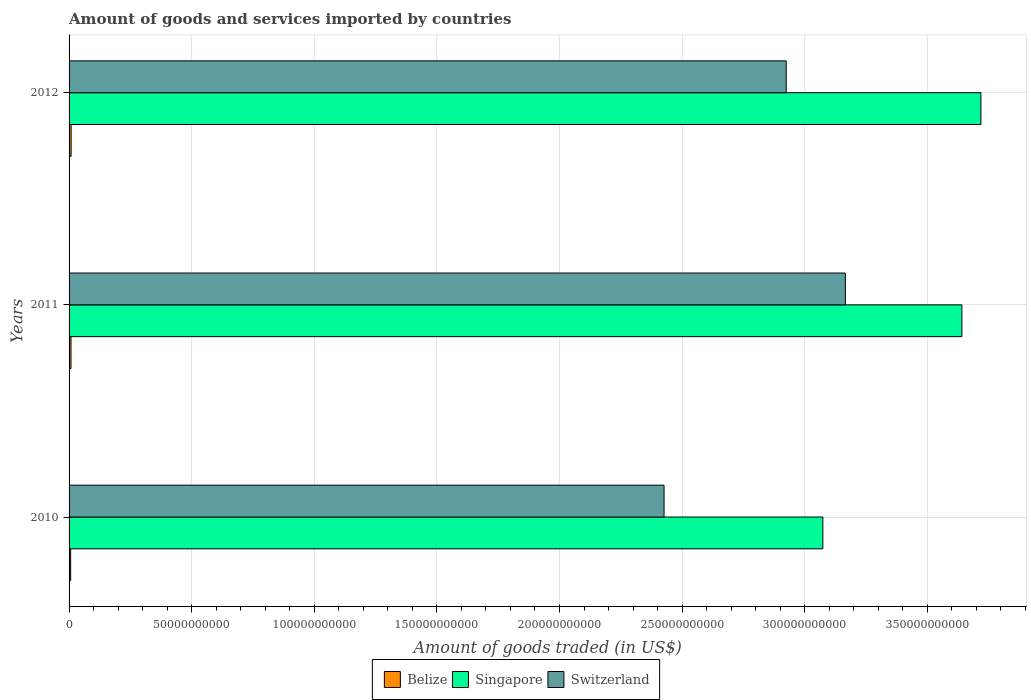How many different coloured bars are there?
Keep it short and to the point. 3. What is the total amount of goods and services imported in Singapore in 2012?
Your answer should be compact. 3.72e+11. Across all years, what is the maximum total amount of goods and services imported in Switzerland?
Your answer should be compact. 3.17e+11. Across all years, what is the minimum total amount of goods and services imported in Switzerland?
Your response must be concise. 2.43e+11. In which year was the total amount of goods and services imported in Switzerland maximum?
Your response must be concise. 2011. What is the total total amount of goods and services imported in Switzerland in the graph?
Your answer should be compact. 8.52e+11. What is the difference between the total amount of goods and services imported in Singapore in 2010 and that in 2011?
Provide a succinct answer. -5.67e+1. What is the difference between the total amount of goods and services imported in Switzerland in 2011 and the total amount of goods and services imported in Belize in 2012?
Ensure brevity in your answer.  3.16e+11. What is the average total amount of goods and services imported in Belize per year?
Provide a short and direct response. 7.54e+08. In the year 2010, what is the difference between the total amount of goods and services imported in Switzerland and total amount of goods and services imported in Belize?
Give a very brief answer. 2.42e+11. In how many years, is the total amount of goods and services imported in Switzerland greater than 170000000000 US$?
Keep it short and to the point. 3. What is the ratio of the total amount of goods and services imported in Switzerland in 2010 to that in 2011?
Offer a terse response. 0.77. What is the difference between the highest and the second highest total amount of goods and services imported in Belize?
Provide a short and direct response. 5.88e+07. What is the difference between the highest and the lowest total amount of goods and services imported in Singapore?
Offer a terse response. 6.45e+1. In how many years, is the total amount of goods and services imported in Singapore greater than the average total amount of goods and services imported in Singapore taken over all years?
Offer a very short reply. 2. What does the 3rd bar from the top in 2012 represents?
Keep it short and to the point. Belize. What does the 2nd bar from the bottom in 2012 represents?
Provide a short and direct response. Singapore. Is it the case that in every year, the sum of the total amount of goods and services imported in Belize and total amount of goods and services imported in Switzerland is greater than the total amount of goods and services imported in Singapore?
Your response must be concise. No. How many bars are there?
Your answer should be very brief. 9. Are all the bars in the graph horizontal?
Give a very brief answer. Yes. What is the difference between two consecutive major ticks on the X-axis?
Your response must be concise. 5.00e+1. How are the legend labels stacked?
Your answer should be very brief. Horizontal. What is the title of the graph?
Your answer should be very brief. Amount of goods and services imported by countries. Does "World" appear as one of the legend labels in the graph?
Provide a succinct answer. No. What is the label or title of the X-axis?
Keep it short and to the point. Amount of goods traded (in US$). What is the label or title of the Y-axis?
Give a very brief answer. Years. What is the Amount of goods traded (in US$) in Belize in 2010?
Your answer should be very brief. 6.47e+08. What is the Amount of goods traded (in US$) of Singapore in 2010?
Your answer should be very brief. 3.07e+11. What is the Amount of goods traded (in US$) in Switzerland in 2010?
Ensure brevity in your answer.  2.43e+11. What is the Amount of goods traded (in US$) of Belize in 2011?
Your answer should be compact. 7.78e+08. What is the Amount of goods traded (in US$) of Singapore in 2011?
Your response must be concise. 3.64e+11. What is the Amount of goods traded (in US$) in Switzerland in 2011?
Provide a succinct answer. 3.17e+11. What is the Amount of goods traded (in US$) of Belize in 2012?
Your answer should be very brief. 8.37e+08. What is the Amount of goods traded (in US$) in Singapore in 2012?
Your response must be concise. 3.72e+11. What is the Amount of goods traded (in US$) of Switzerland in 2012?
Your answer should be very brief. 2.92e+11. Across all years, what is the maximum Amount of goods traded (in US$) of Belize?
Provide a short and direct response. 8.37e+08. Across all years, what is the maximum Amount of goods traded (in US$) in Singapore?
Offer a very short reply. 3.72e+11. Across all years, what is the maximum Amount of goods traded (in US$) in Switzerland?
Offer a very short reply. 3.17e+11. Across all years, what is the minimum Amount of goods traded (in US$) of Belize?
Provide a short and direct response. 6.47e+08. Across all years, what is the minimum Amount of goods traded (in US$) of Singapore?
Your answer should be very brief. 3.07e+11. Across all years, what is the minimum Amount of goods traded (in US$) of Switzerland?
Offer a very short reply. 2.43e+11. What is the total Amount of goods traded (in US$) in Belize in the graph?
Your answer should be very brief. 2.26e+09. What is the total Amount of goods traded (in US$) in Singapore in the graph?
Make the answer very short. 1.04e+12. What is the total Amount of goods traded (in US$) in Switzerland in the graph?
Your answer should be compact. 8.52e+11. What is the difference between the Amount of goods traded (in US$) of Belize in 2010 and that in 2011?
Your answer should be compact. -1.31e+08. What is the difference between the Amount of goods traded (in US$) of Singapore in 2010 and that in 2011?
Keep it short and to the point. -5.67e+1. What is the difference between the Amount of goods traded (in US$) of Switzerland in 2010 and that in 2011?
Your answer should be compact. -7.39e+1. What is the difference between the Amount of goods traded (in US$) in Belize in 2010 and that in 2012?
Make the answer very short. -1.90e+08. What is the difference between the Amount of goods traded (in US$) of Singapore in 2010 and that in 2012?
Ensure brevity in your answer.  -6.45e+1. What is the difference between the Amount of goods traded (in US$) of Switzerland in 2010 and that in 2012?
Your answer should be compact. -4.98e+1. What is the difference between the Amount of goods traded (in US$) in Belize in 2011 and that in 2012?
Offer a terse response. -5.88e+07. What is the difference between the Amount of goods traded (in US$) of Singapore in 2011 and that in 2012?
Your answer should be very brief. -7.76e+09. What is the difference between the Amount of goods traded (in US$) in Switzerland in 2011 and that in 2012?
Offer a very short reply. 2.41e+1. What is the difference between the Amount of goods traded (in US$) of Belize in 2010 and the Amount of goods traded (in US$) of Singapore in 2011?
Provide a succinct answer. -3.63e+11. What is the difference between the Amount of goods traded (in US$) of Belize in 2010 and the Amount of goods traded (in US$) of Switzerland in 2011?
Your answer should be compact. -3.16e+11. What is the difference between the Amount of goods traded (in US$) in Singapore in 2010 and the Amount of goods traded (in US$) in Switzerland in 2011?
Your answer should be compact. -9.18e+09. What is the difference between the Amount of goods traded (in US$) of Belize in 2010 and the Amount of goods traded (in US$) of Singapore in 2012?
Give a very brief answer. -3.71e+11. What is the difference between the Amount of goods traded (in US$) in Belize in 2010 and the Amount of goods traded (in US$) in Switzerland in 2012?
Provide a succinct answer. -2.92e+11. What is the difference between the Amount of goods traded (in US$) of Singapore in 2010 and the Amount of goods traded (in US$) of Switzerland in 2012?
Your answer should be compact. 1.49e+1. What is the difference between the Amount of goods traded (in US$) of Belize in 2011 and the Amount of goods traded (in US$) of Singapore in 2012?
Ensure brevity in your answer.  -3.71e+11. What is the difference between the Amount of goods traded (in US$) in Belize in 2011 and the Amount of goods traded (in US$) in Switzerland in 2012?
Ensure brevity in your answer.  -2.92e+11. What is the difference between the Amount of goods traded (in US$) in Singapore in 2011 and the Amount of goods traded (in US$) in Switzerland in 2012?
Your answer should be compact. 7.16e+1. What is the average Amount of goods traded (in US$) of Belize per year?
Your response must be concise. 7.54e+08. What is the average Amount of goods traded (in US$) in Singapore per year?
Offer a very short reply. 3.48e+11. What is the average Amount of goods traded (in US$) of Switzerland per year?
Make the answer very short. 2.84e+11. In the year 2010, what is the difference between the Amount of goods traded (in US$) of Belize and Amount of goods traded (in US$) of Singapore?
Provide a succinct answer. -3.07e+11. In the year 2010, what is the difference between the Amount of goods traded (in US$) in Belize and Amount of goods traded (in US$) in Switzerland?
Provide a succinct answer. -2.42e+11. In the year 2010, what is the difference between the Amount of goods traded (in US$) of Singapore and Amount of goods traded (in US$) of Switzerland?
Provide a short and direct response. 6.48e+1. In the year 2011, what is the difference between the Amount of goods traded (in US$) of Belize and Amount of goods traded (in US$) of Singapore?
Your answer should be compact. -3.63e+11. In the year 2011, what is the difference between the Amount of goods traded (in US$) of Belize and Amount of goods traded (in US$) of Switzerland?
Give a very brief answer. -3.16e+11. In the year 2011, what is the difference between the Amount of goods traded (in US$) in Singapore and Amount of goods traded (in US$) in Switzerland?
Offer a terse response. 4.75e+1. In the year 2012, what is the difference between the Amount of goods traded (in US$) in Belize and Amount of goods traded (in US$) in Singapore?
Keep it short and to the point. -3.71e+11. In the year 2012, what is the difference between the Amount of goods traded (in US$) in Belize and Amount of goods traded (in US$) in Switzerland?
Your response must be concise. -2.92e+11. In the year 2012, what is the difference between the Amount of goods traded (in US$) in Singapore and Amount of goods traded (in US$) in Switzerland?
Offer a very short reply. 7.94e+1. What is the ratio of the Amount of goods traded (in US$) of Belize in 2010 to that in 2011?
Offer a terse response. 0.83. What is the ratio of the Amount of goods traded (in US$) in Singapore in 2010 to that in 2011?
Make the answer very short. 0.84. What is the ratio of the Amount of goods traded (in US$) in Switzerland in 2010 to that in 2011?
Make the answer very short. 0.77. What is the ratio of the Amount of goods traded (in US$) of Belize in 2010 to that in 2012?
Give a very brief answer. 0.77. What is the ratio of the Amount of goods traded (in US$) in Singapore in 2010 to that in 2012?
Make the answer very short. 0.83. What is the ratio of the Amount of goods traded (in US$) in Switzerland in 2010 to that in 2012?
Offer a terse response. 0.83. What is the ratio of the Amount of goods traded (in US$) of Belize in 2011 to that in 2012?
Your answer should be compact. 0.93. What is the ratio of the Amount of goods traded (in US$) in Singapore in 2011 to that in 2012?
Keep it short and to the point. 0.98. What is the ratio of the Amount of goods traded (in US$) of Switzerland in 2011 to that in 2012?
Give a very brief answer. 1.08. What is the difference between the highest and the second highest Amount of goods traded (in US$) in Belize?
Give a very brief answer. 5.88e+07. What is the difference between the highest and the second highest Amount of goods traded (in US$) in Singapore?
Your answer should be compact. 7.76e+09. What is the difference between the highest and the second highest Amount of goods traded (in US$) of Switzerland?
Give a very brief answer. 2.41e+1. What is the difference between the highest and the lowest Amount of goods traded (in US$) in Belize?
Ensure brevity in your answer.  1.90e+08. What is the difference between the highest and the lowest Amount of goods traded (in US$) in Singapore?
Your answer should be compact. 6.45e+1. What is the difference between the highest and the lowest Amount of goods traded (in US$) of Switzerland?
Give a very brief answer. 7.39e+1. 